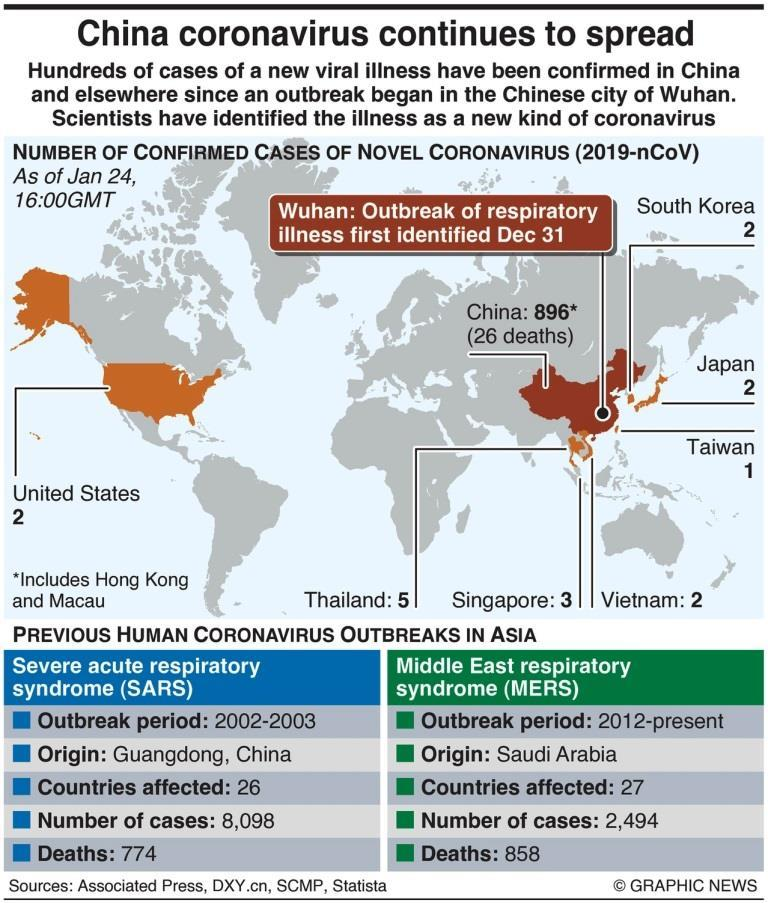List a handful of essential elements in this visual. The SARS virus was first identified in China in 2002. The SARS disease outbreak affected 26 countries. The first case of SARS was identified in Guangdong, China. In total, 8,098 cases of SARS virus were reported. The first case of MERS was identified in Saudi Arabia. 